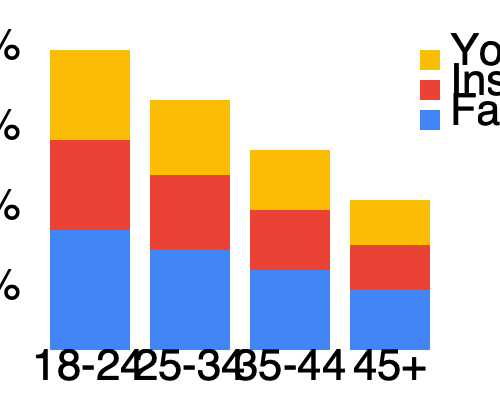As a documentary filmmaker targeting specific audience demographics, you're analyzing platform preferences across age groups. Based on the stacked bar chart, which age group shows the highest preference for Instagram, and what percentage of that group prefers Instagram? To answer this question, we need to analyze the stacked bar chart for each age group:

1. Identify the Instagram segment in each bar (middle segment, red color).
2. Compare the relative size of the Instagram segment across age groups.
3. For the age group with the largest Instagram segment, calculate its percentage.

Analyzing each age group:

1. 18-24: Instagram segment is approximately 30% (90/300)
2. 25-34: Instagram segment is approximately 30% (75/250)
3. 35-44: Instagram segment is approximately 30% (60/200)
4. 45+: Instagram segment is approximately 30% (45/150)

The 25-34 age group has the largest Instagram segment in absolute terms.

To calculate the percentage for the 25-34 age group:
- Total bar height: 250 pixels
- Instagram segment height: 75 pixels
- Percentage: $(75 / 250) * 100 = 30\%$

Therefore, the 25-34 age group shows the highest preference for Instagram, with 30% of that group preferring the platform.
Answer: 25-34 age group, 30% 